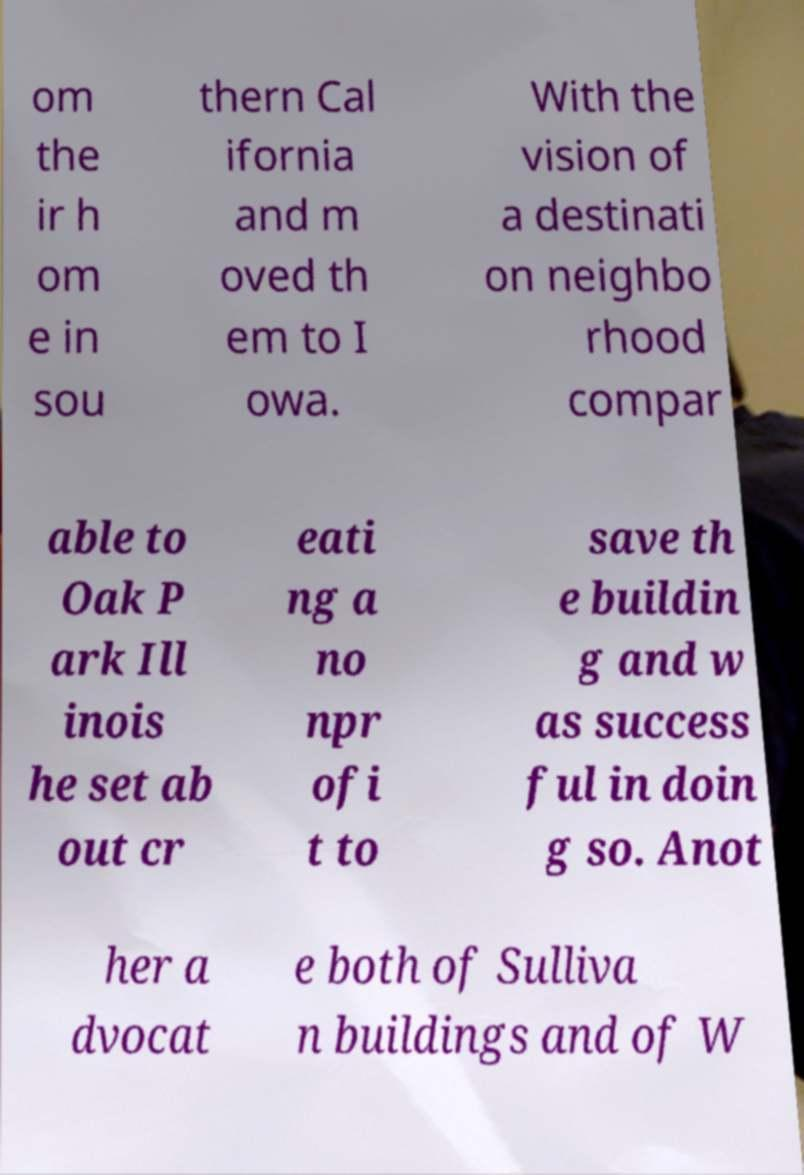What messages or text are displayed in this image? I need them in a readable, typed format. om the ir h om e in sou thern Cal ifornia and m oved th em to I owa. With the vision of a destinati on neighbo rhood compar able to Oak P ark Ill inois he set ab out cr eati ng a no npr ofi t to save th e buildin g and w as success ful in doin g so. Anot her a dvocat e both of Sulliva n buildings and of W 